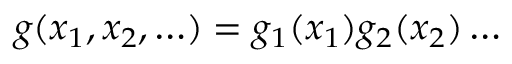<formula> <loc_0><loc_0><loc_500><loc_500>g ( x _ { 1 } , x _ { 2 } , \dots ) = g _ { 1 } ( x _ { 1 } ) g _ { 2 } ( x _ { 2 } ) \dots</formula> 